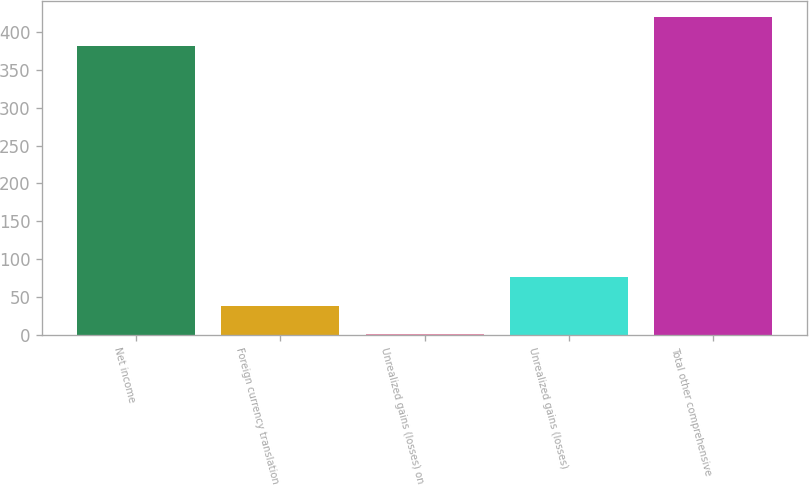Convert chart to OTSL. <chart><loc_0><loc_0><loc_500><loc_500><bar_chart><fcel>Net income<fcel>Foreign currency translation<fcel>Unrealized gains (losses) on<fcel>Unrealized gains (losses)<fcel>Total other comprehensive<nl><fcel>381.8<fcel>38.39<fcel>0.2<fcel>76.58<fcel>419.99<nl></chart> 